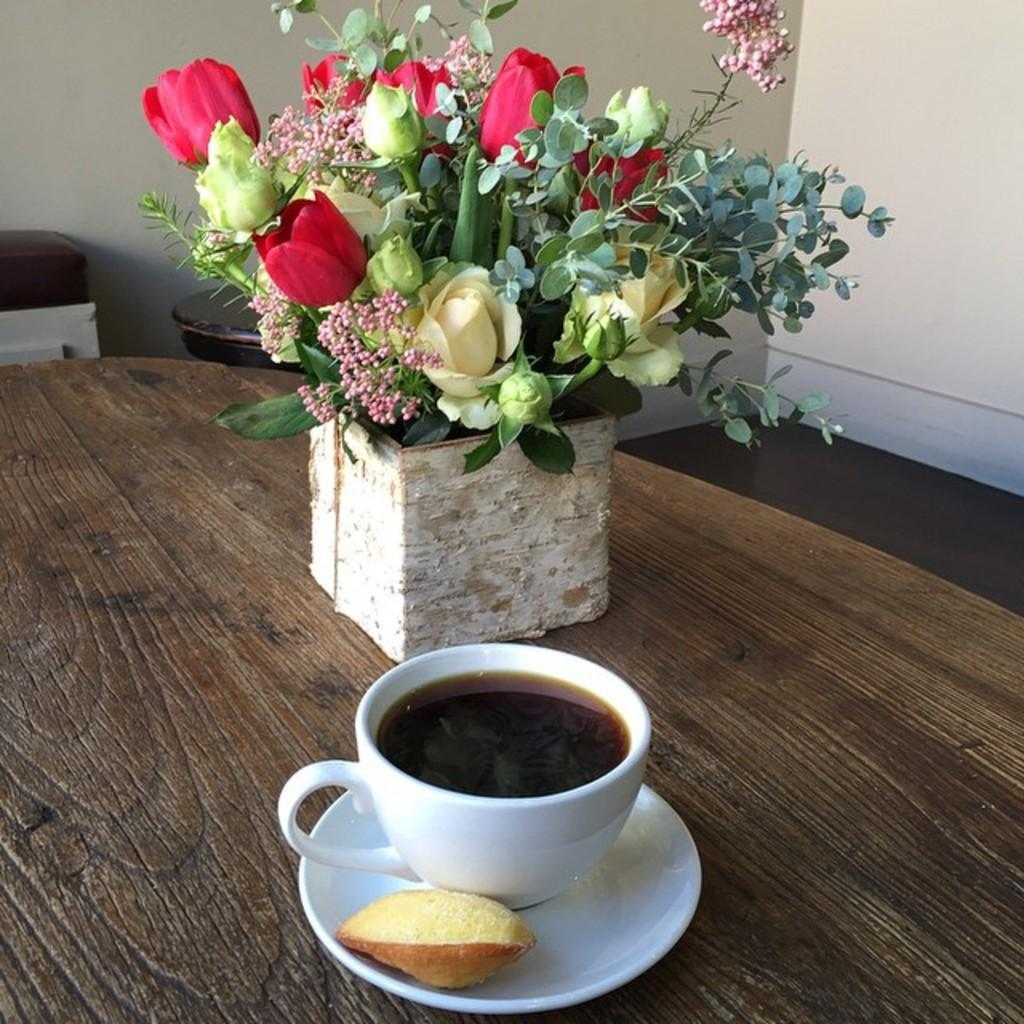What is the main subject of the image? The main subject of the image is a flower bouquet. What other objects are present in the image? There is a pot, a cup, tea, biscuits, and a saucer in the image. How are these objects arranged? The objects are placed on a table. Is there any furniture visible in the image? Yes, there is a chair in the background of the image. What is the scent of the story being told by the father in the image? There is no father or story present in the image; it features a flower bouquet, a pot, a cup, tea, biscuits, and a saucer on a table with a chair in the background. 